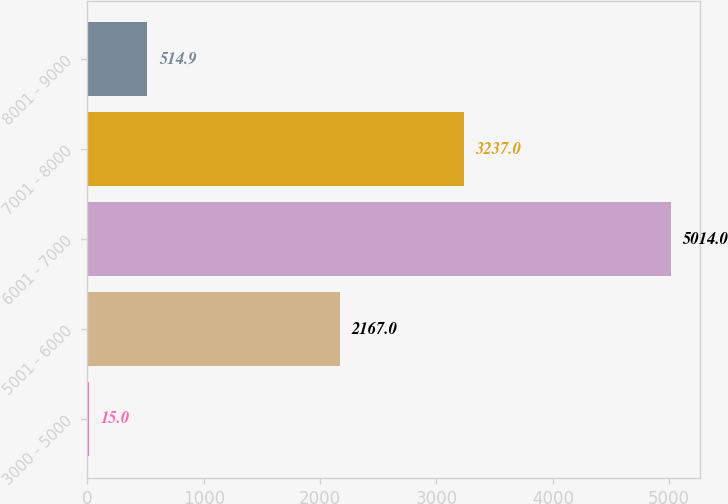Convert chart to OTSL. <chart><loc_0><loc_0><loc_500><loc_500><bar_chart><fcel>3000 - 5000<fcel>5001 - 6000<fcel>6001 - 7000<fcel>7001 - 8000<fcel>8001 - 9000<nl><fcel>15<fcel>2167<fcel>5014<fcel>3237<fcel>514.9<nl></chart> 